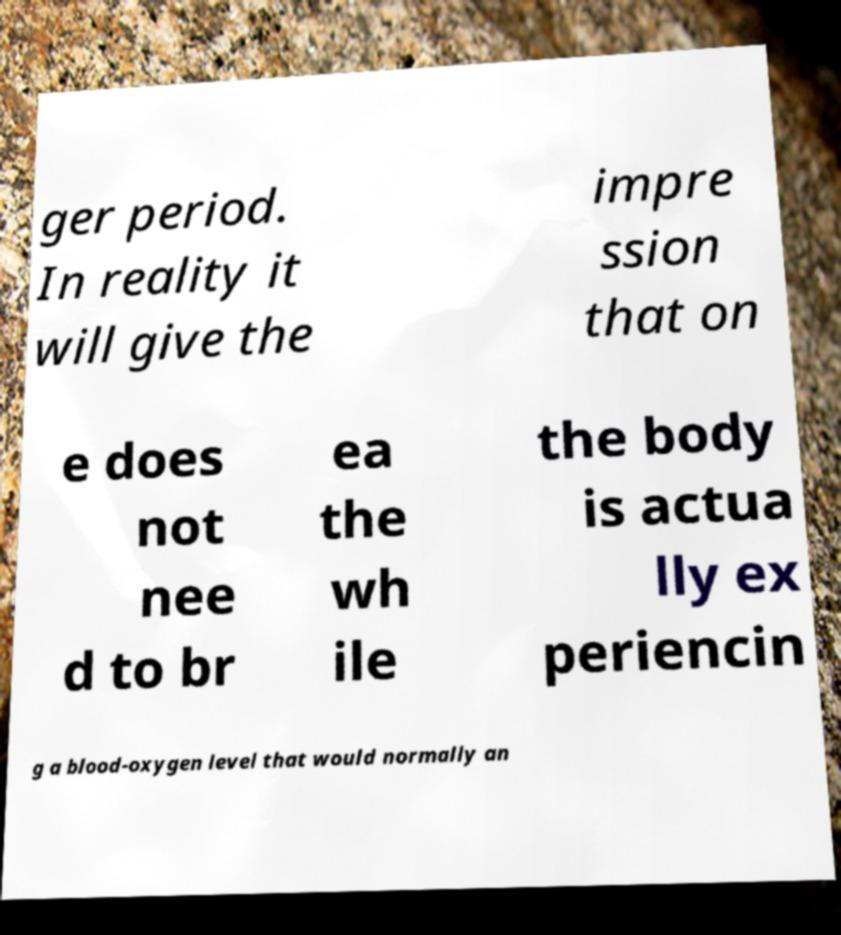Could you extract and type out the text from this image? ger period. In reality it will give the impre ssion that on e does not nee d to br ea the wh ile the body is actua lly ex periencin g a blood-oxygen level that would normally an 